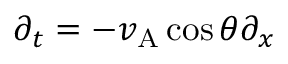<formula> <loc_0><loc_0><loc_500><loc_500>\partial _ { t } = - v _ { A } \cos \theta \partial _ { x }</formula> 